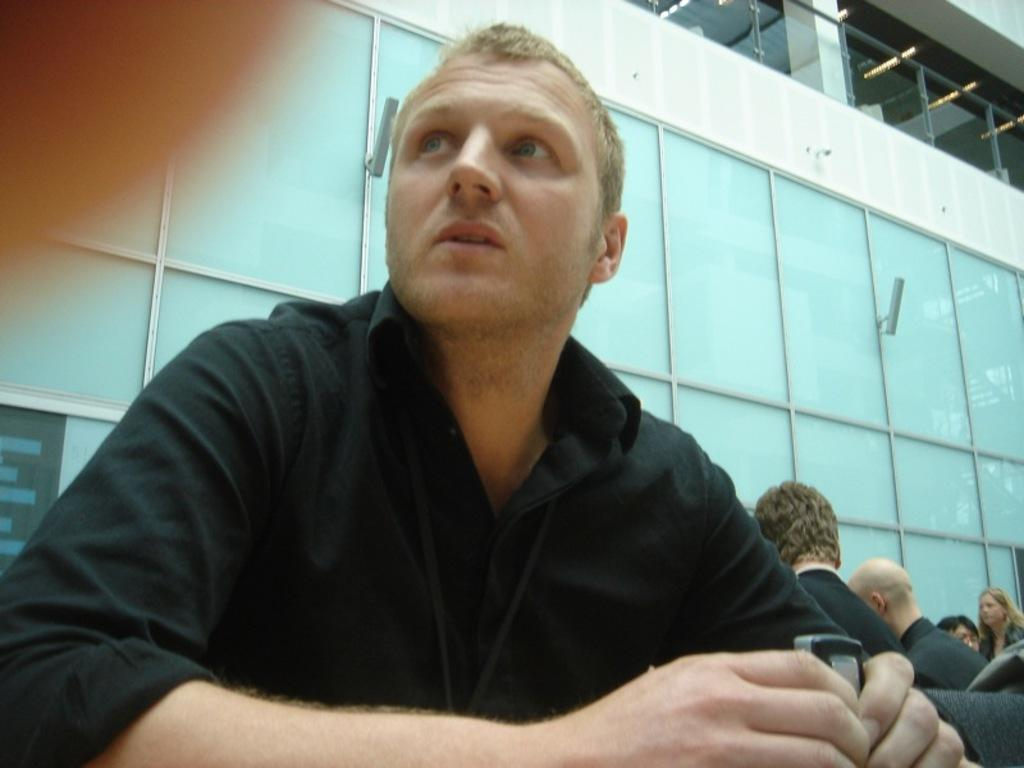What is the person in the image wearing? The person in the image is wearing a black shirt. How many people are in the image? There are other people in the image besides the person wearing the black shirt. What can be seen in the background of the image? There is a building in the image. Can you see any jellyfish in the image? No, there are no jellyfish present in the image. 